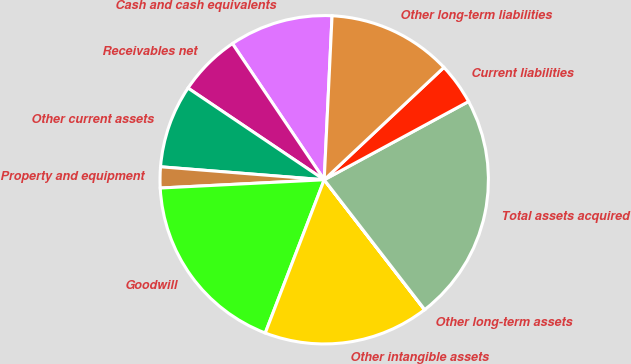<chart> <loc_0><loc_0><loc_500><loc_500><pie_chart><fcel>Cash and cash equivalents<fcel>Receivables net<fcel>Other current assets<fcel>Property and equipment<fcel>Goodwill<fcel>Other intangible assets<fcel>Other long-term assets<fcel>Total assets acquired<fcel>Current liabilities<fcel>Other long-term liabilities<nl><fcel>10.2%<fcel>6.13%<fcel>8.17%<fcel>2.06%<fcel>18.35%<fcel>16.31%<fcel>0.02%<fcel>22.42%<fcel>4.09%<fcel>12.24%<nl></chart> 